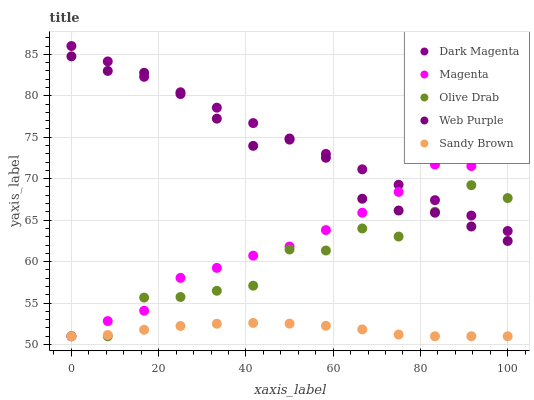Does Sandy Brown have the minimum area under the curve?
Answer yes or no. Yes. Does Dark Magenta have the maximum area under the curve?
Answer yes or no. Yes. Does Magenta have the minimum area under the curve?
Answer yes or no. No. Does Magenta have the maximum area under the curve?
Answer yes or no. No. Is Dark Magenta the smoothest?
Answer yes or no. Yes. Is Olive Drab the roughest?
Answer yes or no. Yes. Is Magenta the smoothest?
Answer yes or no. No. Is Magenta the roughest?
Answer yes or no. No. Does Magenta have the lowest value?
Answer yes or no. Yes. Does Dark Magenta have the lowest value?
Answer yes or no. No. Does Dark Magenta have the highest value?
Answer yes or no. Yes. Does Magenta have the highest value?
Answer yes or no. No. Is Sandy Brown less than Dark Magenta?
Answer yes or no. Yes. Is Dark Magenta greater than Sandy Brown?
Answer yes or no. Yes. Does Olive Drab intersect Web Purple?
Answer yes or no. Yes. Is Olive Drab less than Web Purple?
Answer yes or no. No. Is Olive Drab greater than Web Purple?
Answer yes or no. No. Does Sandy Brown intersect Dark Magenta?
Answer yes or no. No. 